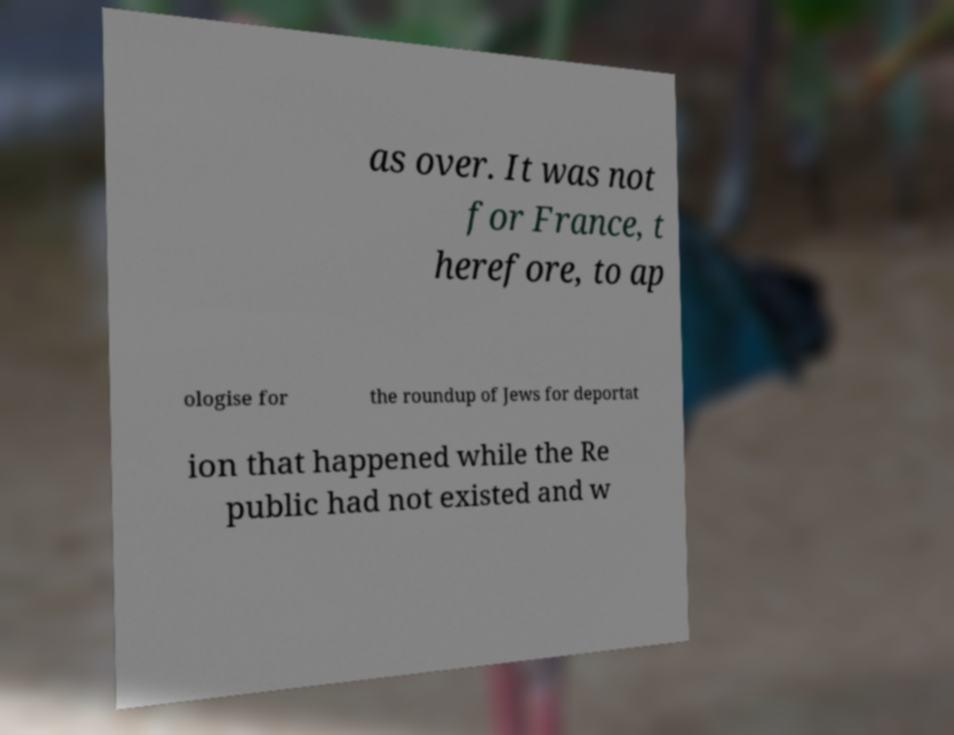Could you extract and type out the text from this image? as over. It was not for France, t herefore, to ap ologise for the roundup of Jews for deportat ion that happened while the Re public had not existed and w 